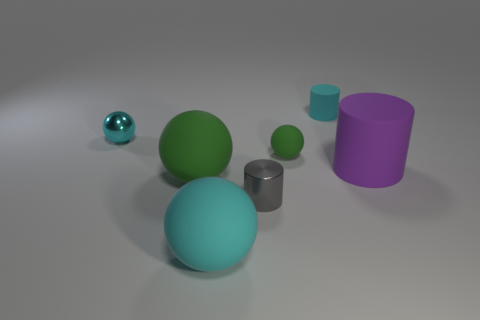Add 1 large cylinders. How many objects exist? 8 Subtract all spheres. How many objects are left? 3 Add 6 tiny matte cylinders. How many tiny matte cylinders exist? 7 Subtract 0 green cylinders. How many objects are left? 7 Subtract all tiny cyan metal objects. Subtract all small cyan balls. How many objects are left? 5 Add 1 small green matte spheres. How many small green matte spheres are left? 2 